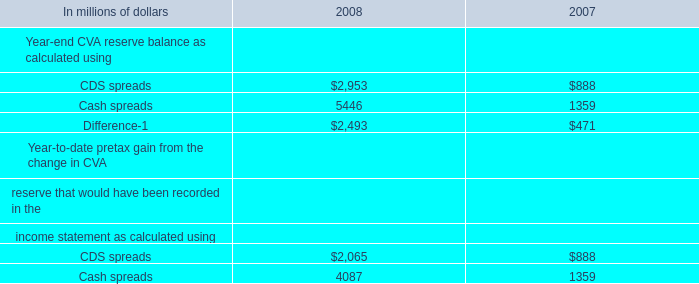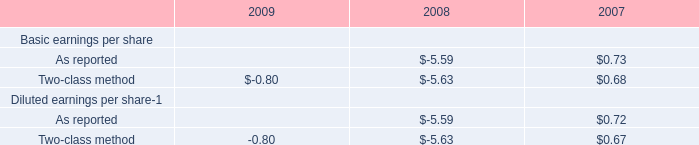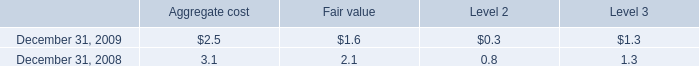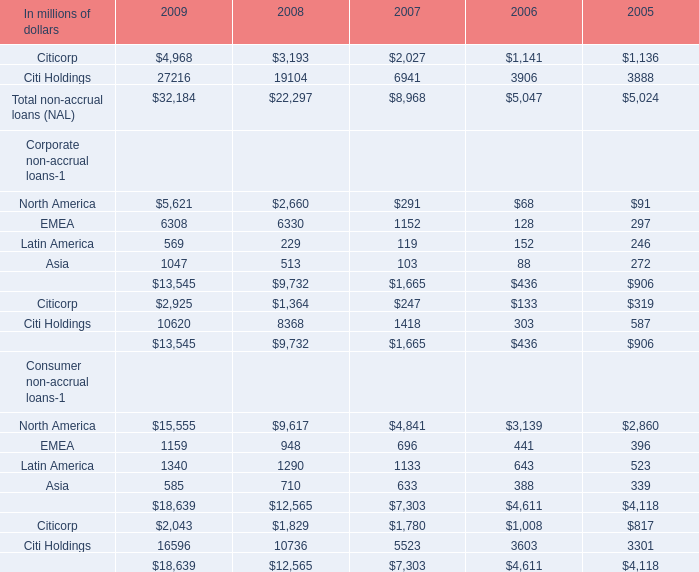What's the average of Citi Holdings of 2006, and Cash spreads of 2008 ? 
Computations: ((3906.0 + 5446.0) / 2)
Answer: 4676.0. 